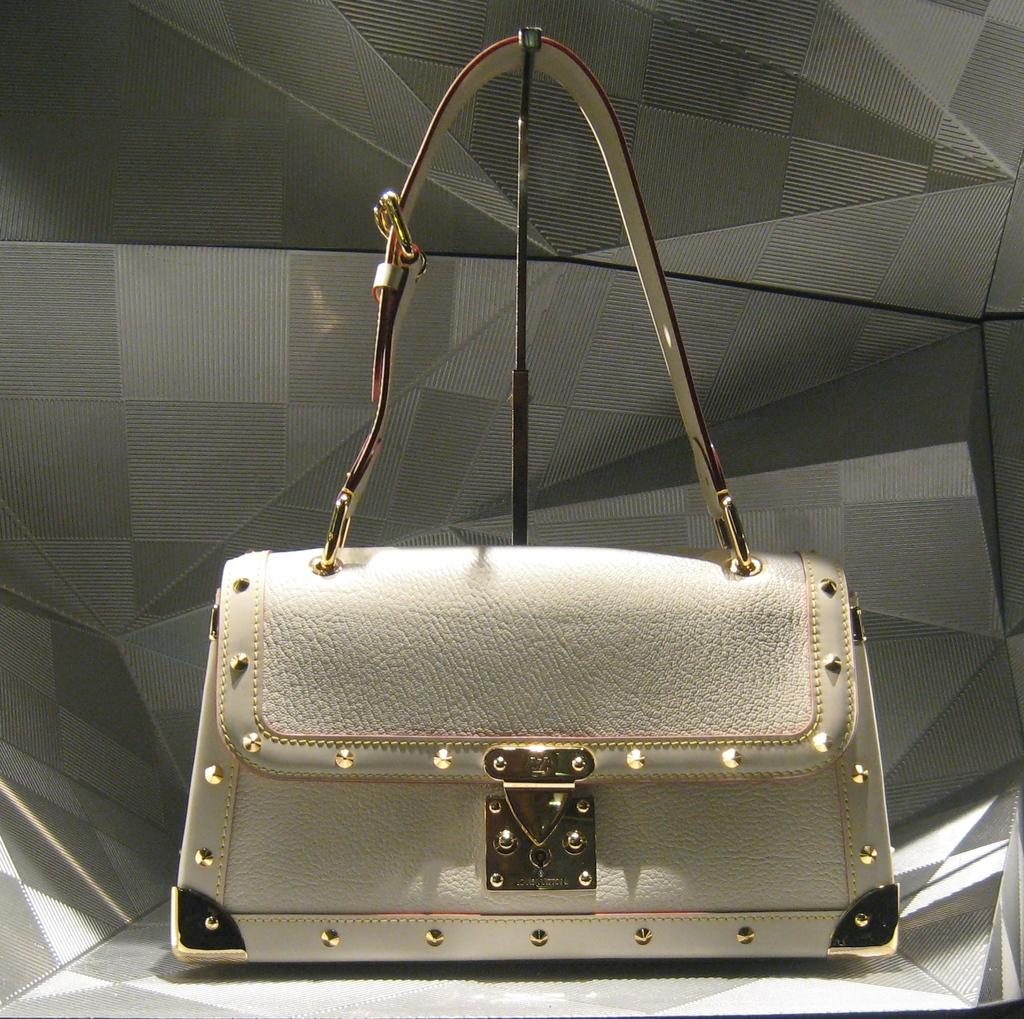What object can be seen in the image? There is a bag in the image. What type of mine is visible in the image? There is no mine present in the image; it only features a bag. Where can you buy the bag shown in the image? The image does not provide information about where the bag can be purchased, nor does it show a shop. 